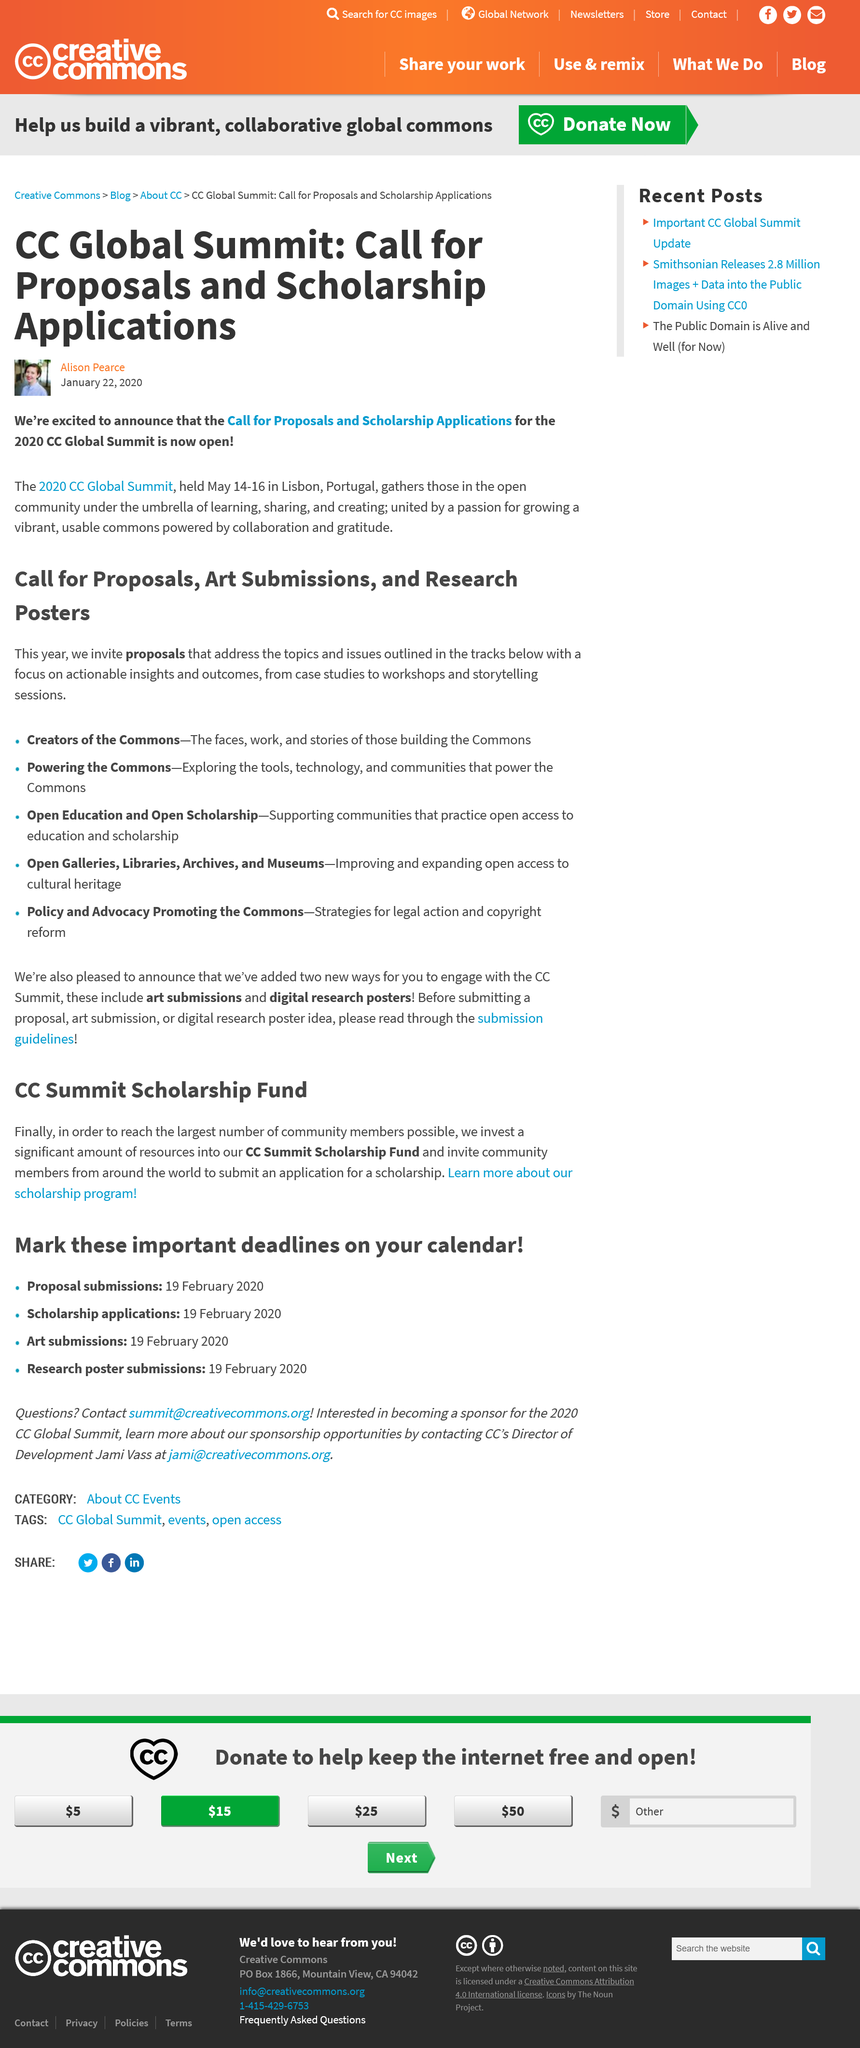Indicate a few pertinent items in this graphic. The Call for Proposals and Scholarship Applications for the 2020 CC Global Summit are currently open. Yes, they do invite community members from around the world to submit an application for a scholarship. Yes, they do invest a significant amount of resources into their CC Summit Scholarship Fund. The CC Summit Scholarship Fund is about providing financial assistance to individuals who are interested in attending the CC Summit but may not be able to afford it. The article was written by Alison Pearce. 